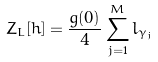<formula> <loc_0><loc_0><loc_500><loc_500>Z _ { L } [ h ] = \frac { g ( 0 ) } { 4 } \sum _ { j = 1 } ^ { M } l _ { \gamma _ { j } }</formula> 